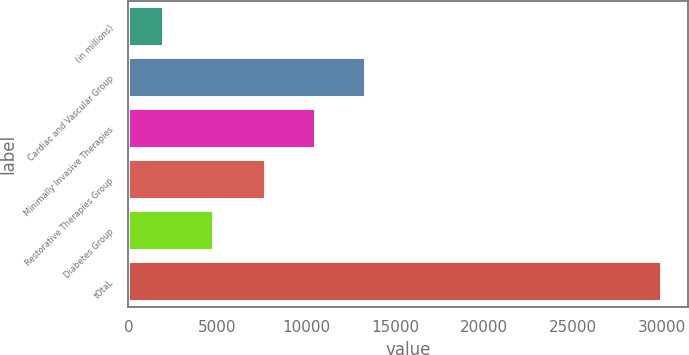<chart> <loc_0><loc_0><loc_500><loc_500><bar_chart><fcel>(in millions)<fcel>Cardiac and Vascular Group<fcel>Minimally Invasive Therapies<fcel>Restorative Therapies Group<fcel>Diabetes Group<fcel>tOtaL<nl><fcel>2018<fcel>13330<fcel>10536.5<fcel>7743<fcel>4811.5<fcel>29953<nl></chart> 